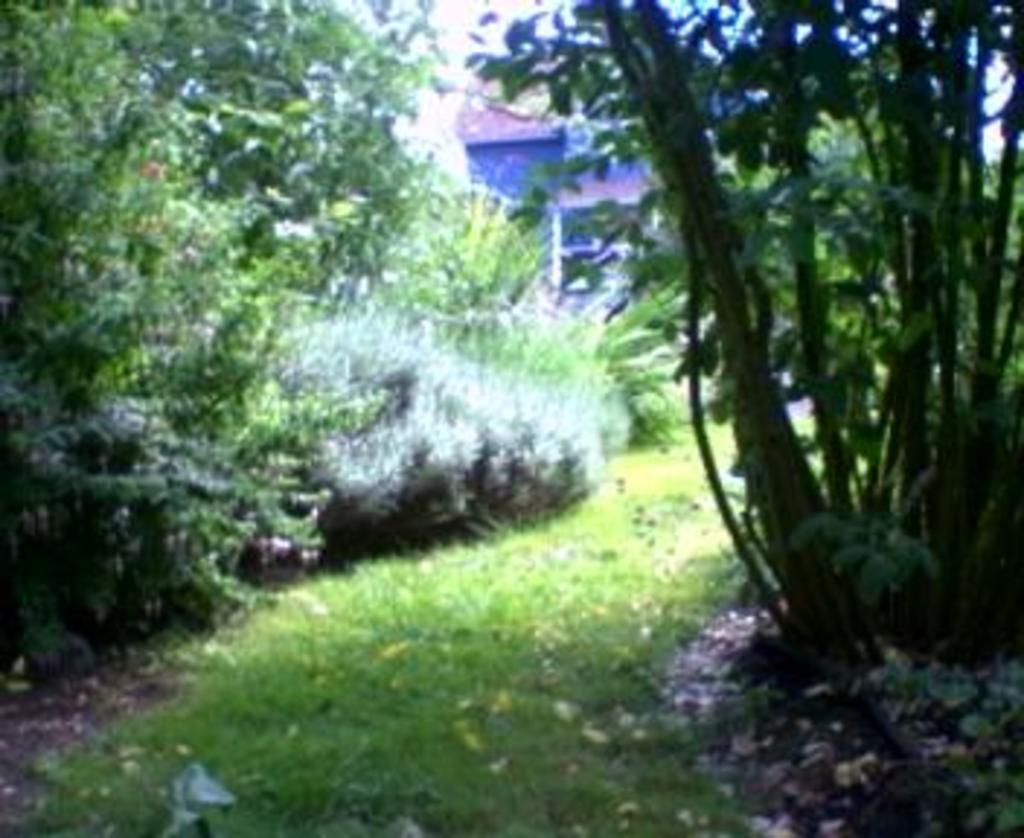What type of vegetation can be seen in the image? There are plants and trees with flowers in the image. Can you describe the trees in the image? The trees in the image have flowers on them. What is visible in the background of the image? There is a house visible in the background of the image. What is the relation between the chin and the park in the image? There is no mention of a chin or a park in the image, so it is not possible to determine any relation between them. 